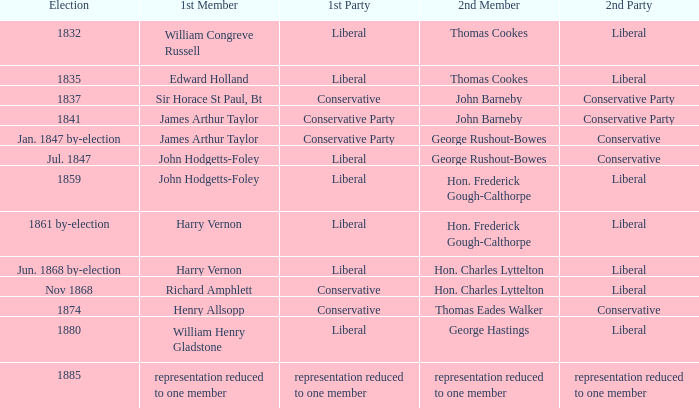What was the 1st Member when the 1st Party had its representation reduced to one member? Representation reduced to one member. 